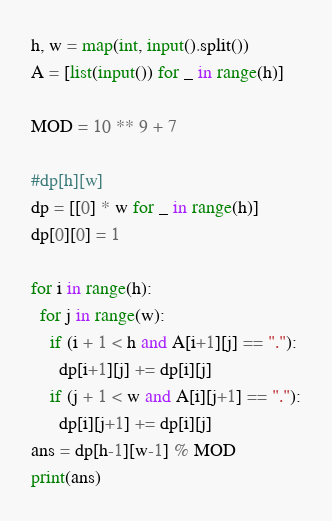<code> <loc_0><loc_0><loc_500><loc_500><_Python_>h, w = map(int, input().split())
A = [list(input()) for _ in range(h)]

MOD = 10 ** 9 + 7

#dp[h][w]
dp = [[0] * w for _ in range(h)]
dp[0][0] = 1

for i in range(h):
  for j in range(w):
    if (i + 1 < h and A[i+1][j] == "."):
      dp[i+1][j] += dp[i][j] 
    if (j + 1 < w and A[i][j+1] == "."):
      dp[i][j+1] += dp[i][j] 
ans = dp[h-1][w-1] % MOD
print(ans)</code> 